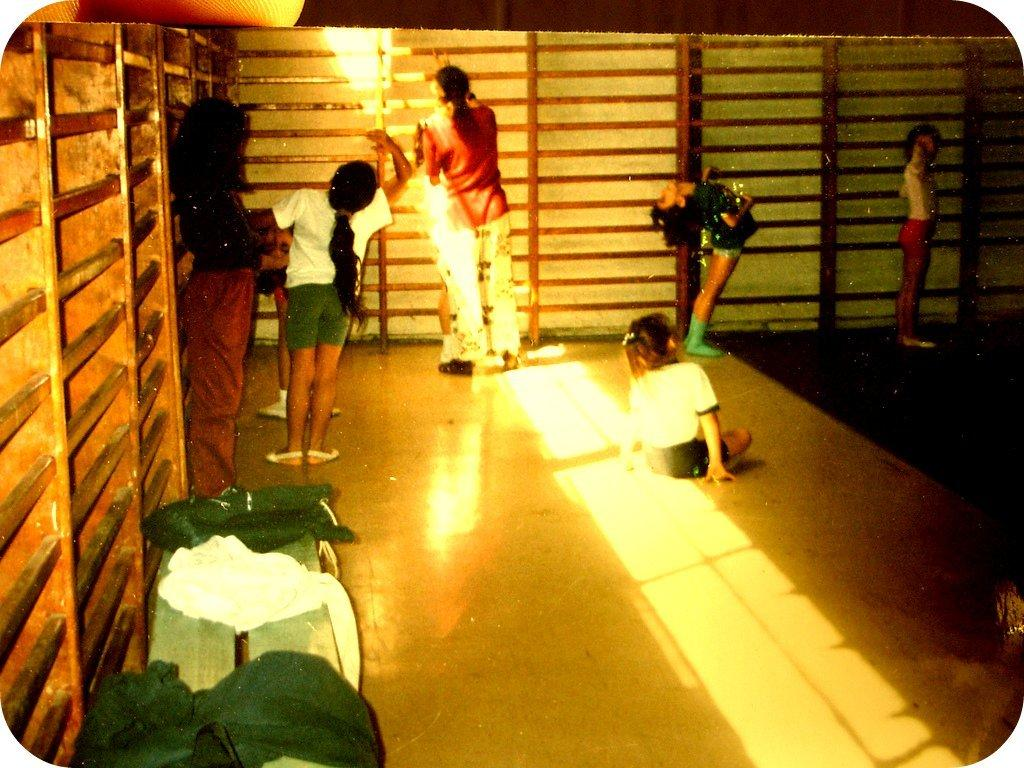What can be seen in the image involving people? There are people standing in the image. What is the surface that the people are standing on? The people are standing on a surface, but the specific type of surface is not mentioned in the facts. What kind of fence is visible in the image? There is a wooden grill fence in the image. What brand of toothpaste is being advertised on the fence in the image? There is no toothpaste or advertisement present in the image; it only features a wooden grill fence. 